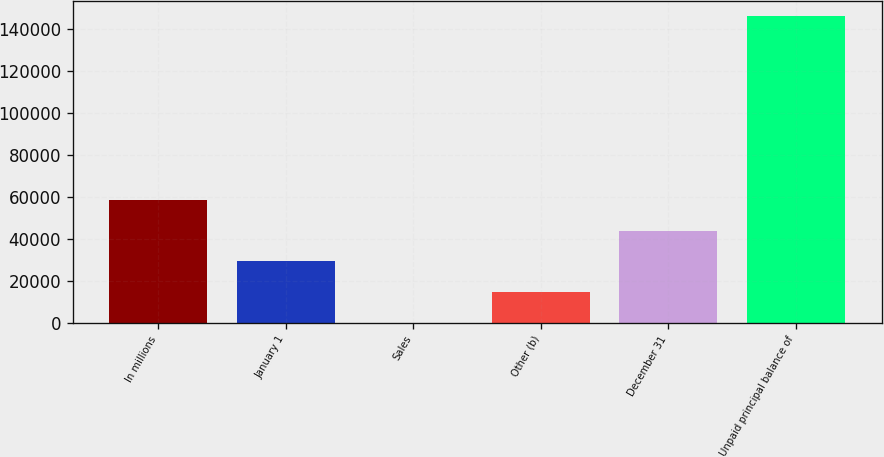Convert chart to OTSL. <chart><loc_0><loc_0><loc_500><loc_500><bar_chart><fcel>In millions<fcel>January 1<fcel>Sales<fcel>Other (b)<fcel>December 31<fcel>Unpaid principal balance of<nl><fcel>58464.4<fcel>29269.2<fcel>74<fcel>14671.6<fcel>43866.8<fcel>146050<nl></chart> 